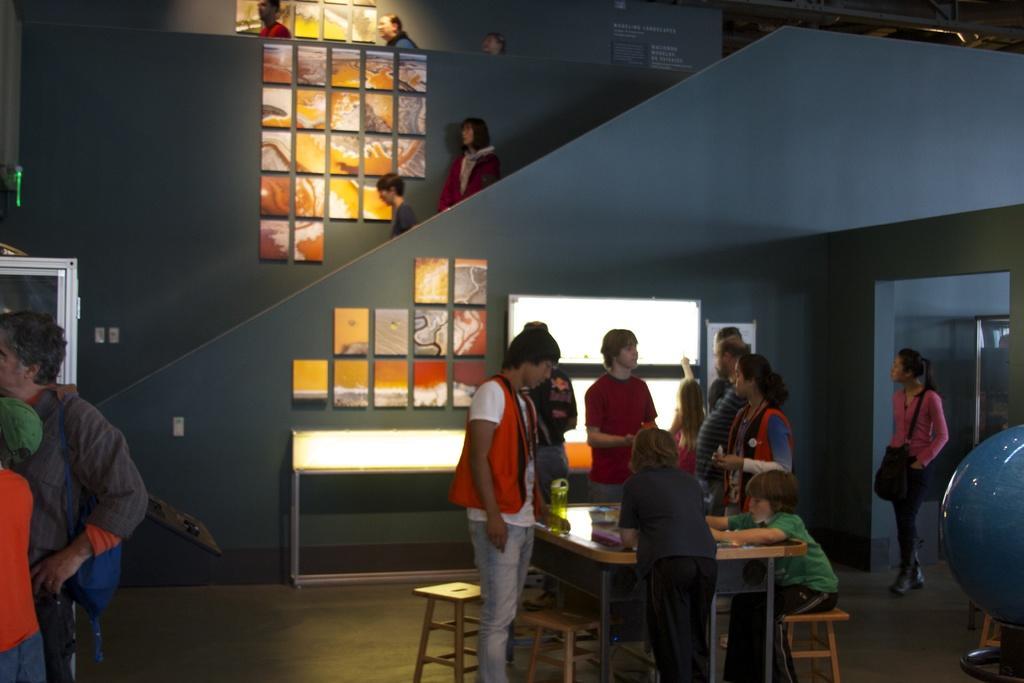Can you describe this image briefly? In this picture there are group of people standing, there is a boy sitting over here, he has a table in front of them and onto the left there are people standing 